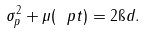Convert formula to latex. <formula><loc_0><loc_0><loc_500><loc_500>\sigma _ { p } ^ { 2 } + \mu ( \ p t ) = 2 \i d .</formula> 